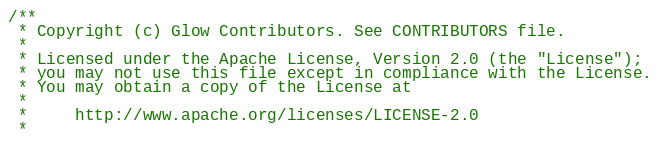Convert code to text. <code><loc_0><loc_0><loc_500><loc_500><_C_>/**
 * Copyright (c) Glow Contributors. See CONTRIBUTORS file.
 *
 * Licensed under the Apache License, Version 2.0 (the "License");
 * you may not use this file except in compliance with the License.
 * You may obtain a copy of the License at
 *
 *     http://www.apache.org/licenses/LICENSE-2.0
 *</code> 